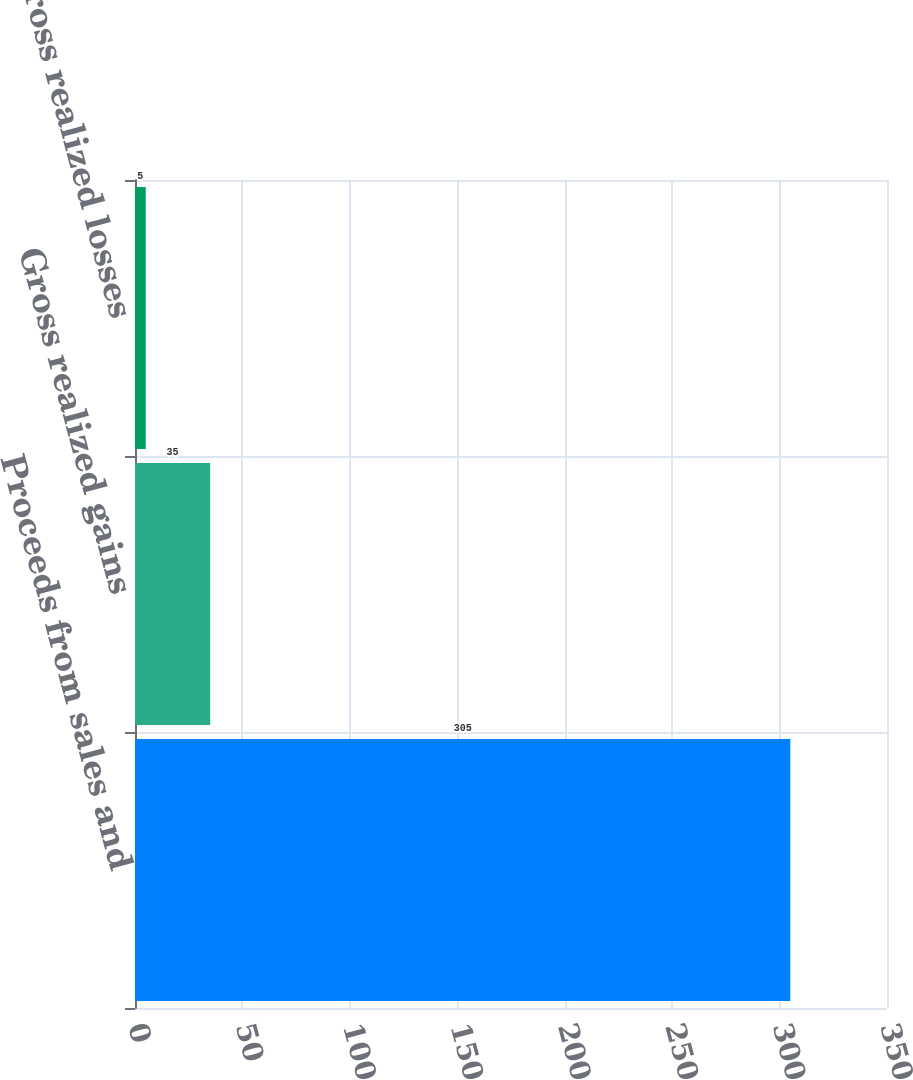<chart> <loc_0><loc_0><loc_500><loc_500><bar_chart><fcel>Proceeds from sales and<fcel>Gross realized gains<fcel>Gross realized losses<nl><fcel>305<fcel>35<fcel>5<nl></chart> 